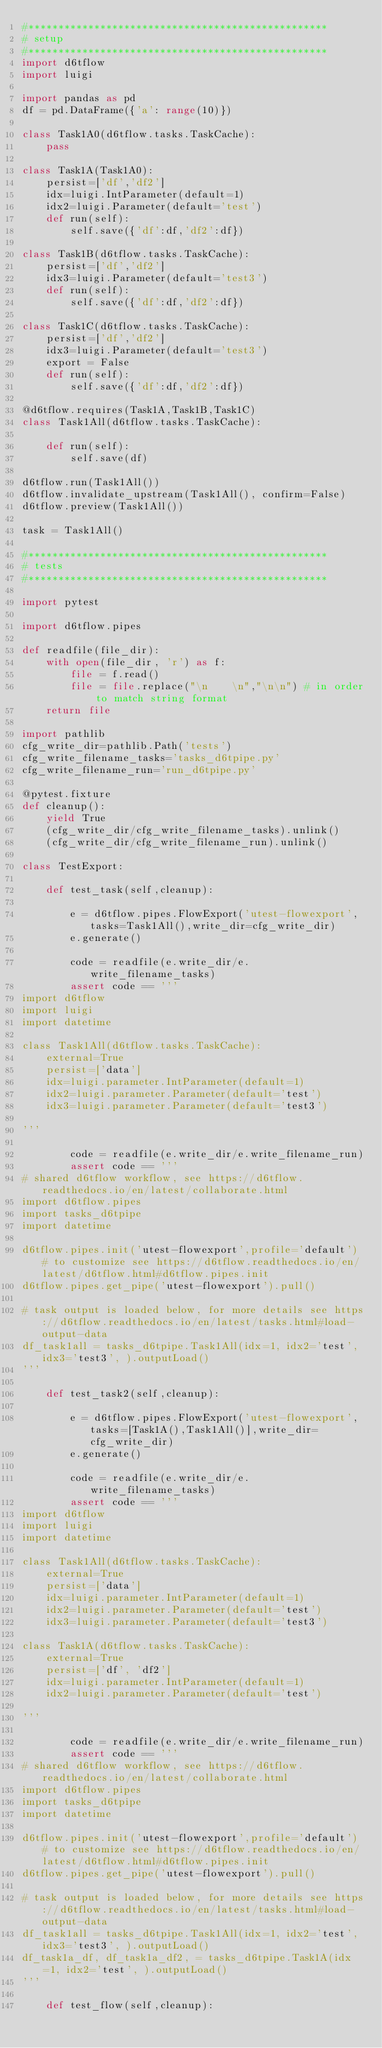<code> <loc_0><loc_0><loc_500><loc_500><_Python_>#**************************************************
# setup
#**************************************************
import d6tflow
import luigi

import pandas as pd
df = pd.DataFrame({'a': range(10)})

class Task1A0(d6tflow.tasks.TaskCache):
    pass

class Task1A(Task1A0):
    persist=['df','df2']
    idx=luigi.IntParameter(default=1)
    idx2=luigi.Parameter(default='test')
    def run(self):
        self.save({'df':df,'df2':df})

class Task1B(d6tflow.tasks.TaskCache):
    persist=['df','df2']
    idx3=luigi.Parameter(default='test3')
    def run(self):
        self.save({'df':df,'df2':df})

class Task1C(d6tflow.tasks.TaskCache):
    persist=['df','df2']
    idx3=luigi.Parameter(default='test3')
    export = False
    def run(self):
        self.save({'df':df,'df2':df})

@d6tflow.requires(Task1A,Task1B,Task1C)
class Task1All(d6tflow.tasks.TaskCache):

    def run(self):
        self.save(df)

d6tflow.run(Task1All())
d6tflow.invalidate_upstream(Task1All(), confirm=False)
d6tflow.preview(Task1All())

task = Task1All()

#**************************************************
# tests
#**************************************************

import pytest

import d6tflow.pipes

def readfile(file_dir):
    with open(file_dir, 'r') as f:
        file = f.read()
        file = file.replace("\n    \n","\n\n") # in order to match string format
    return file

import pathlib
cfg_write_dir=pathlib.Path('tests')
cfg_write_filename_tasks='tasks_d6tpipe.py'
cfg_write_filename_run='run_d6tpipe.py'

@pytest.fixture
def cleanup():
    yield True
    (cfg_write_dir/cfg_write_filename_tasks).unlink()
    (cfg_write_dir/cfg_write_filename_run).unlink()

class TestExport:

    def test_task(self,cleanup):

        e = d6tflow.pipes.FlowExport('utest-flowexport',tasks=Task1All(),write_dir=cfg_write_dir)
        e.generate()

        code = readfile(e.write_dir/e.write_filename_tasks)
        assert code == '''
import d6tflow
import luigi
import datetime

class Task1All(d6tflow.tasks.TaskCache):
    external=True
    persist=['data']
    idx=luigi.parameter.IntParameter(default=1)
    idx2=luigi.parameter.Parameter(default='test')
    idx3=luigi.parameter.Parameter(default='test3')

'''

        code = readfile(e.write_dir/e.write_filename_run)
        assert code == '''
# shared d6tflow workflow, see https://d6tflow.readthedocs.io/en/latest/collaborate.html
import d6tflow.pipes
import tasks_d6tpipe
import datetime

d6tflow.pipes.init('utest-flowexport',profile='default') # to customize see https://d6tflow.readthedocs.io/en/latest/d6tflow.html#d6tflow.pipes.init
d6tflow.pipes.get_pipe('utest-flowexport').pull()

# task output is loaded below, for more details see https://d6tflow.readthedocs.io/en/latest/tasks.html#load-output-data
df_task1all = tasks_d6tpipe.Task1All(idx=1, idx2='test', idx3='test3', ).outputLoad()
'''

    def test_task2(self,cleanup):

        e = d6tflow.pipes.FlowExport('utest-flowexport',tasks=[Task1A(),Task1All()],write_dir=cfg_write_dir)
        e.generate()

        code = readfile(e.write_dir/e.write_filename_tasks)
        assert code == '''
import d6tflow
import luigi
import datetime

class Task1All(d6tflow.tasks.TaskCache):
    external=True
    persist=['data']
    idx=luigi.parameter.IntParameter(default=1)
    idx2=luigi.parameter.Parameter(default='test')
    idx3=luigi.parameter.Parameter(default='test3')

class Task1A(d6tflow.tasks.TaskCache):
    external=True
    persist=['df', 'df2']
    idx=luigi.parameter.IntParameter(default=1)
    idx2=luigi.parameter.Parameter(default='test')

'''

        code = readfile(e.write_dir/e.write_filename_run)
        assert code == '''
# shared d6tflow workflow, see https://d6tflow.readthedocs.io/en/latest/collaborate.html
import d6tflow.pipes
import tasks_d6tpipe
import datetime

d6tflow.pipes.init('utest-flowexport',profile='default') # to customize see https://d6tflow.readthedocs.io/en/latest/d6tflow.html#d6tflow.pipes.init
d6tflow.pipes.get_pipe('utest-flowexport').pull()

# task output is loaded below, for more details see https://d6tflow.readthedocs.io/en/latest/tasks.html#load-output-data
df_task1all = tasks_d6tpipe.Task1All(idx=1, idx2='test', idx3='test3', ).outputLoad()
df_task1a_df, df_task1a_df2, = tasks_d6tpipe.Task1A(idx=1, idx2='test', ).outputLoad()
'''

    def test_flow(self,cleanup):
</code> 